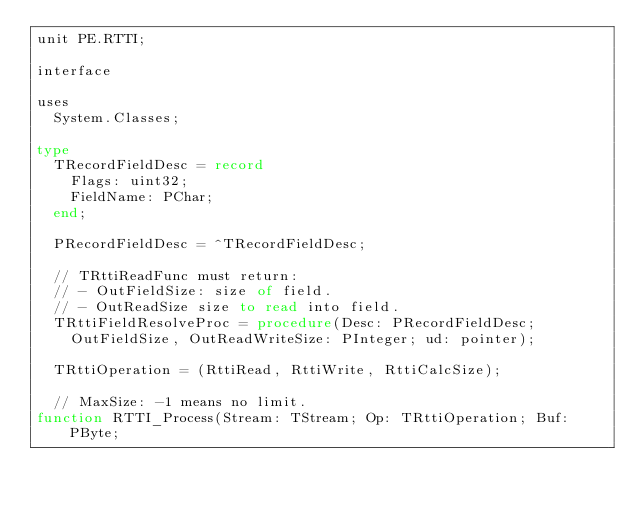Convert code to text. <code><loc_0><loc_0><loc_500><loc_500><_Pascal_>unit PE.RTTI;

interface

uses
  System.Classes;

type
  TRecordFieldDesc = record
    Flags: uint32;
    FieldName: PChar;
  end;

  PRecordFieldDesc = ^TRecordFieldDesc;

  // TRttiReadFunc must return:
  // - OutFieldSize: size of field.
  // - OutReadSize size to read into field.
  TRttiFieldResolveProc = procedure(Desc: PRecordFieldDesc;
    OutFieldSize, OutReadWriteSize: PInteger; ud: pointer);

  TRttiOperation = (RttiRead, RttiWrite, RttiCalcSize);

  // MaxSize: -1 means no limit.
function RTTI_Process(Stream: TStream; Op: TRttiOperation; Buf: PByte;</code> 